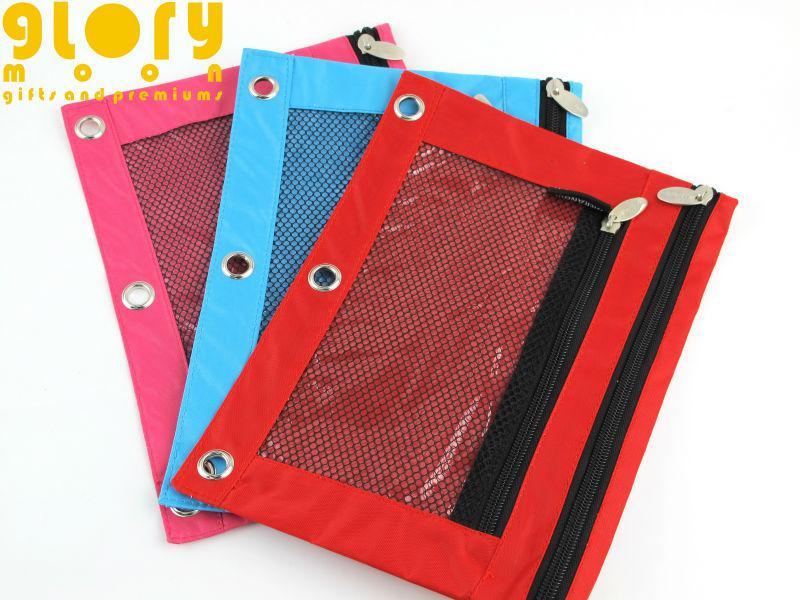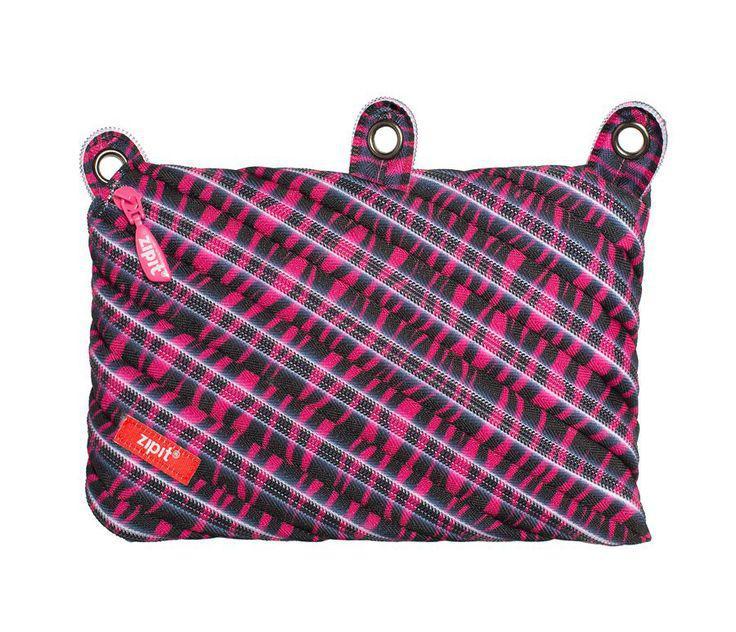The first image is the image on the left, the second image is the image on the right. Given the left and right images, does the statement "An image shows an open three-ring binder containing a pencil case, and the other image includes a pencil case that is not in a binder." hold true? Answer yes or no. No. The first image is the image on the left, the second image is the image on the right. For the images shown, is this caption "writing utensils are sticking out of every single pencil case." true? Answer yes or no. No. 